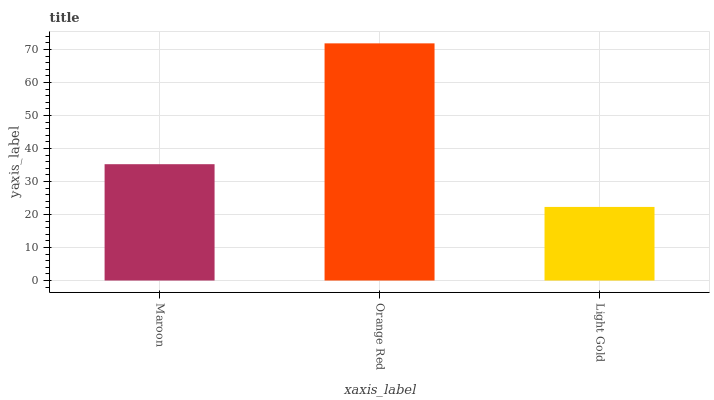Is Light Gold the minimum?
Answer yes or no. Yes. Is Orange Red the maximum?
Answer yes or no. Yes. Is Orange Red the minimum?
Answer yes or no. No. Is Light Gold the maximum?
Answer yes or no. No. Is Orange Red greater than Light Gold?
Answer yes or no. Yes. Is Light Gold less than Orange Red?
Answer yes or no. Yes. Is Light Gold greater than Orange Red?
Answer yes or no. No. Is Orange Red less than Light Gold?
Answer yes or no. No. Is Maroon the high median?
Answer yes or no. Yes. Is Maroon the low median?
Answer yes or no. Yes. Is Orange Red the high median?
Answer yes or no. No. Is Orange Red the low median?
Answer yes or no. No. 